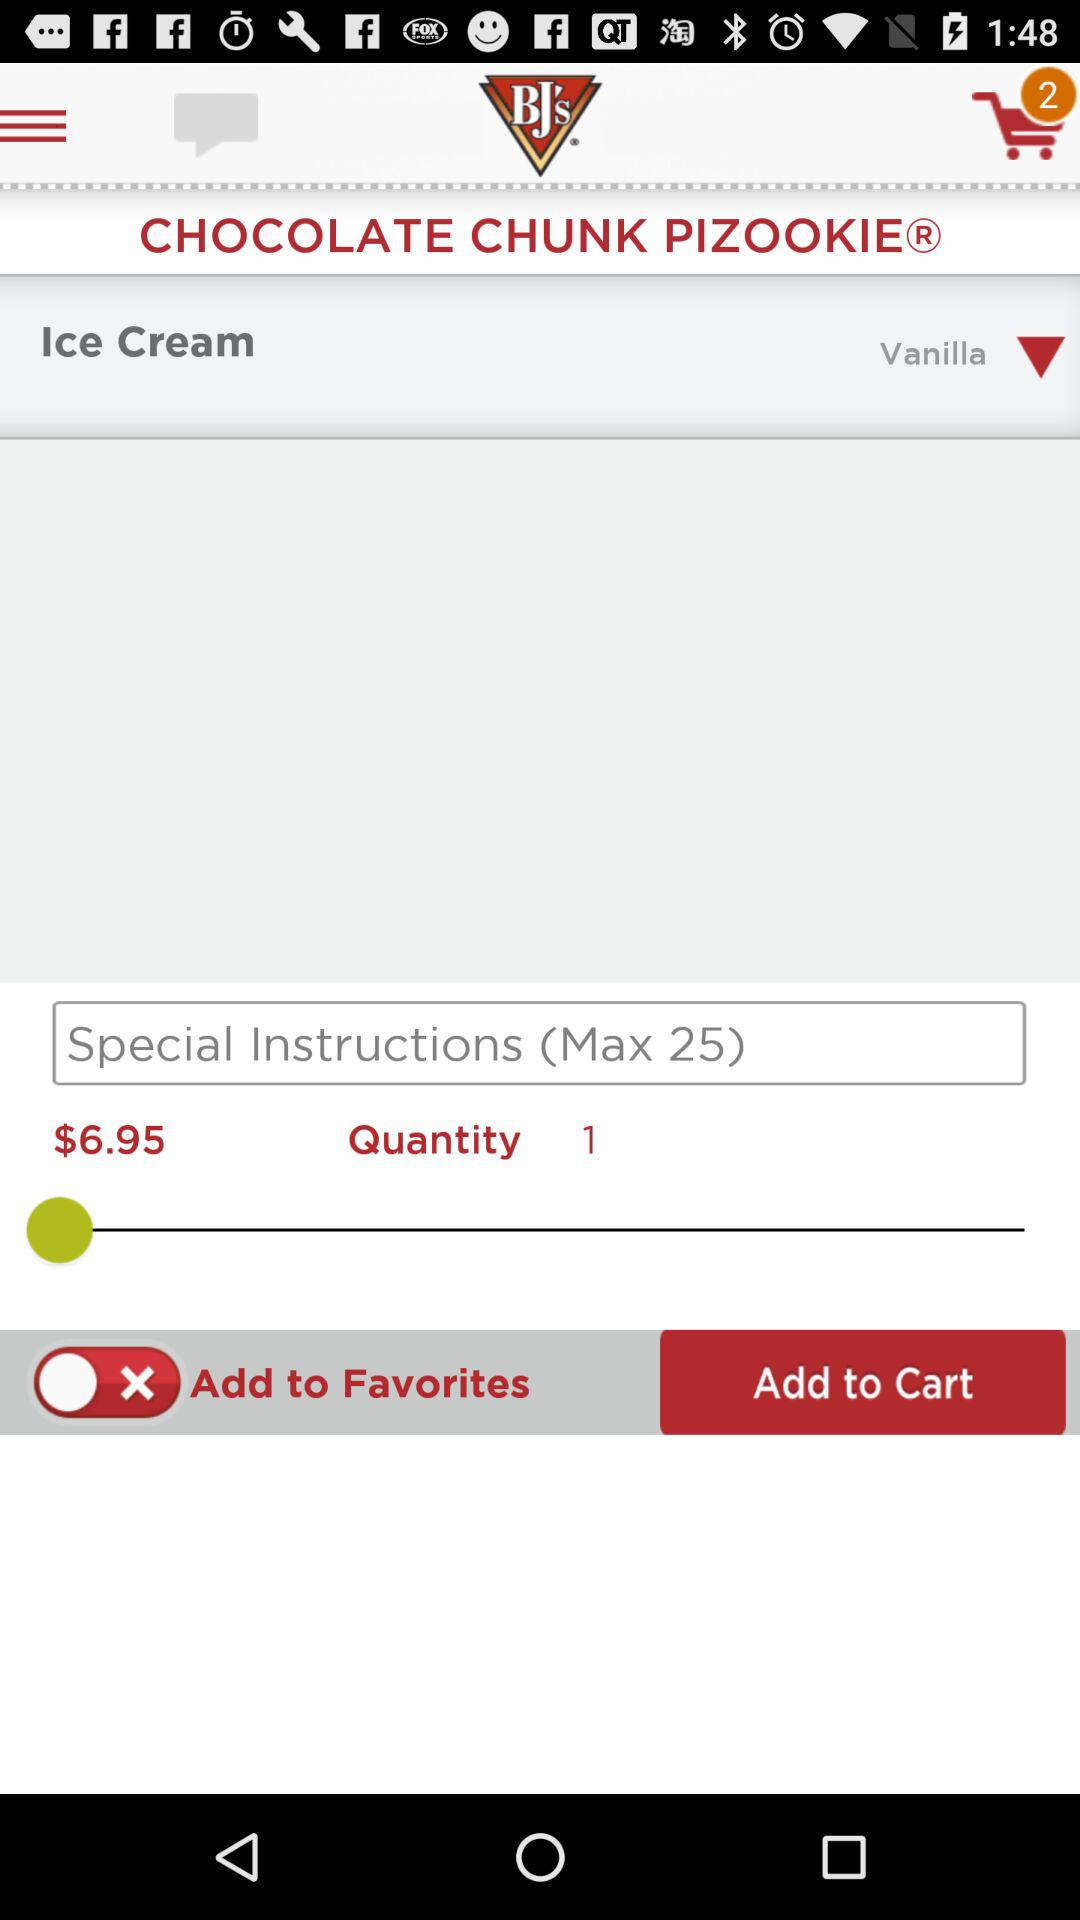What is the maximum number of characters for special instructions? The maximum number of characters for special instructions is 25. 